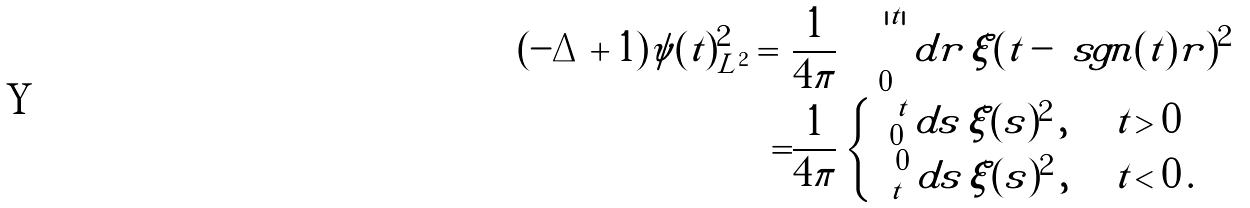Convert formula to latex. <formula><loc_0><loc_0><loc_500><loc_500>\| ( - \Delta + 1 ) \psi ( t ) \| ^ { 2 } _ { L ^ { 2 } } = & \frac { 1 } { 4 \pi } \int _ { 0 } ^ { | t | } d r \, | \xi ( t - \ s g n ( t ) r ) | ^ { 2 } \\ = & \frac { 1 } { 4 \pi } \begin{cases} \int _ { 0 } ^ { t } d s \, | \xi ( s ) | ^ { 2 } \, , & t > 0 \\ \int _ { t } ^ { 0 } d s \, | \xi ( s ) | ^ { 2 } \, , & t < 0 \, . \end{cases}</formula> 